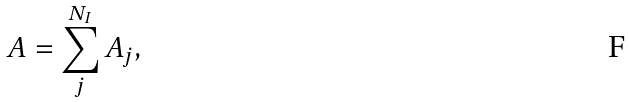<formula> <loc_0><loc_0><loc_500><loc_500>A = \sum _ { j } ^ { N _ { I } } A _ { j } ,</formula> 